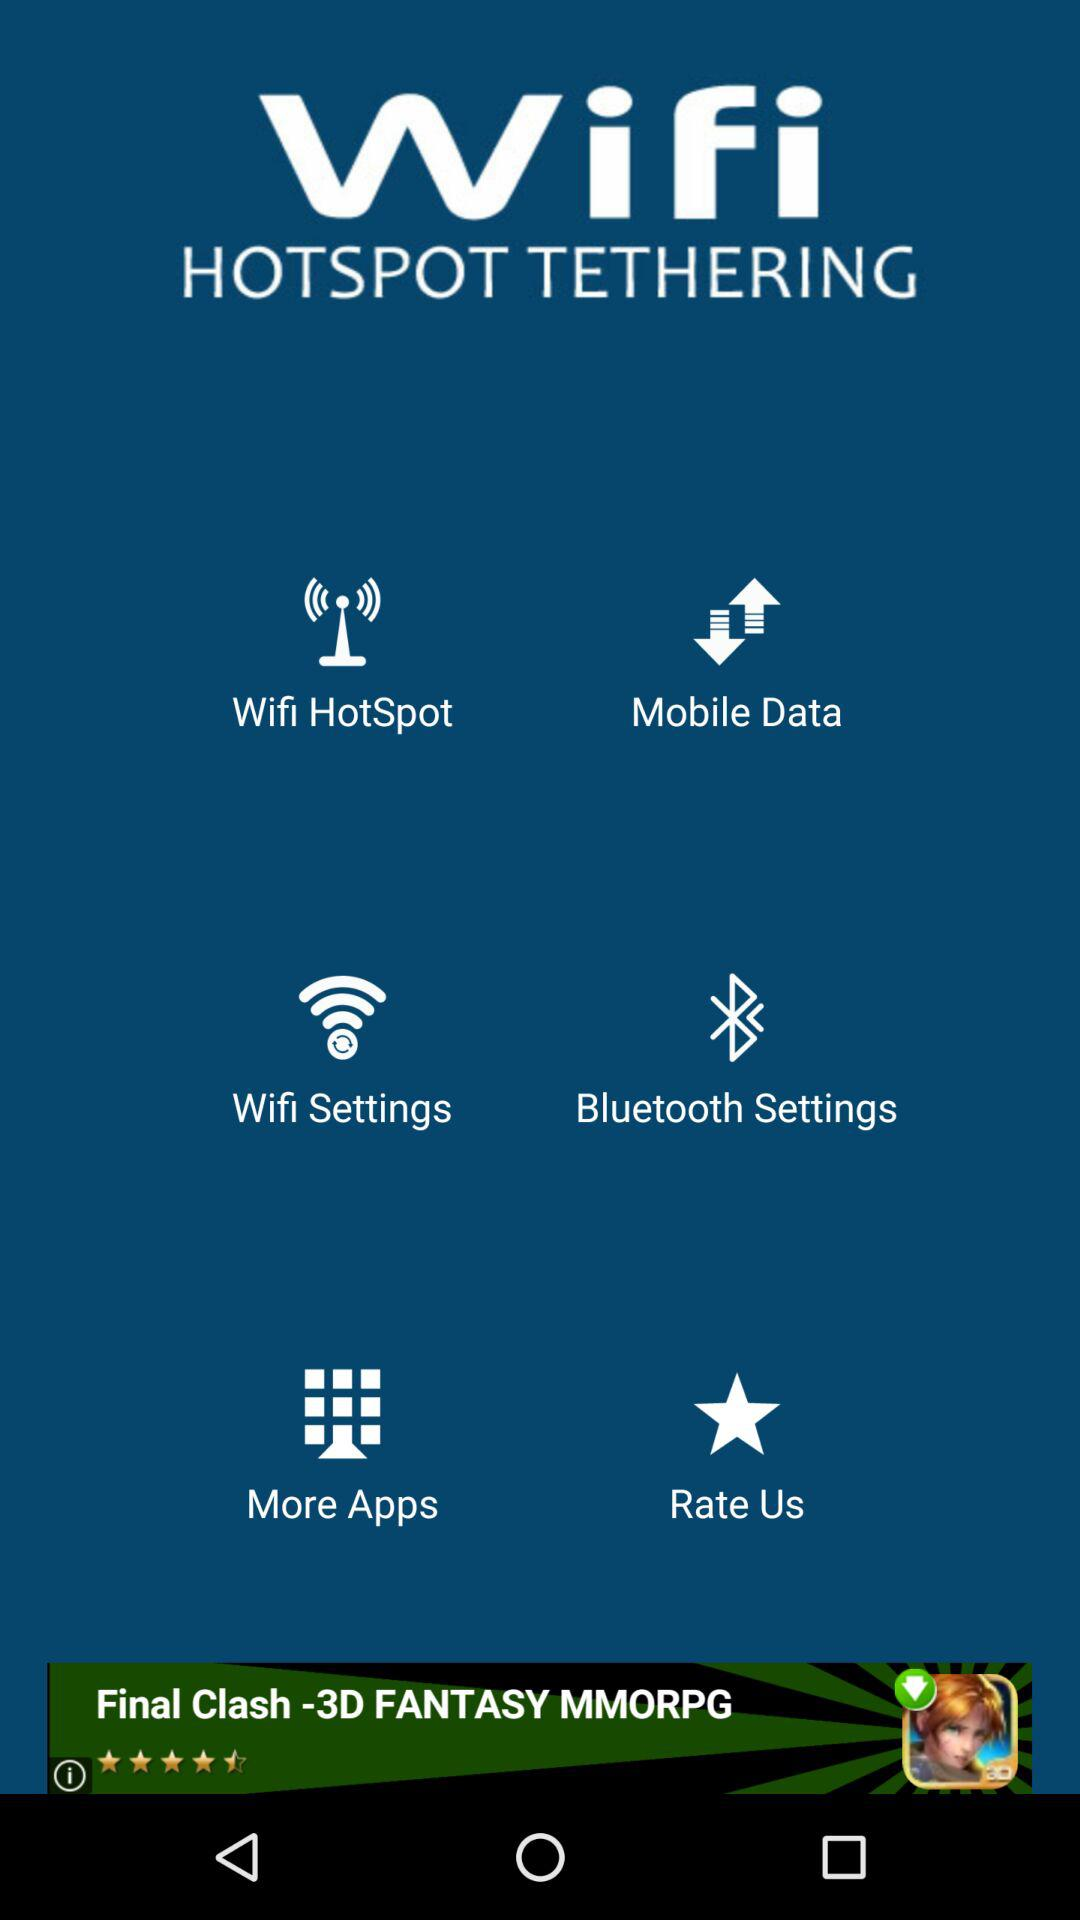What is the name of the application? The name of the application is "Wifi HOTSPOT TETHERING". 